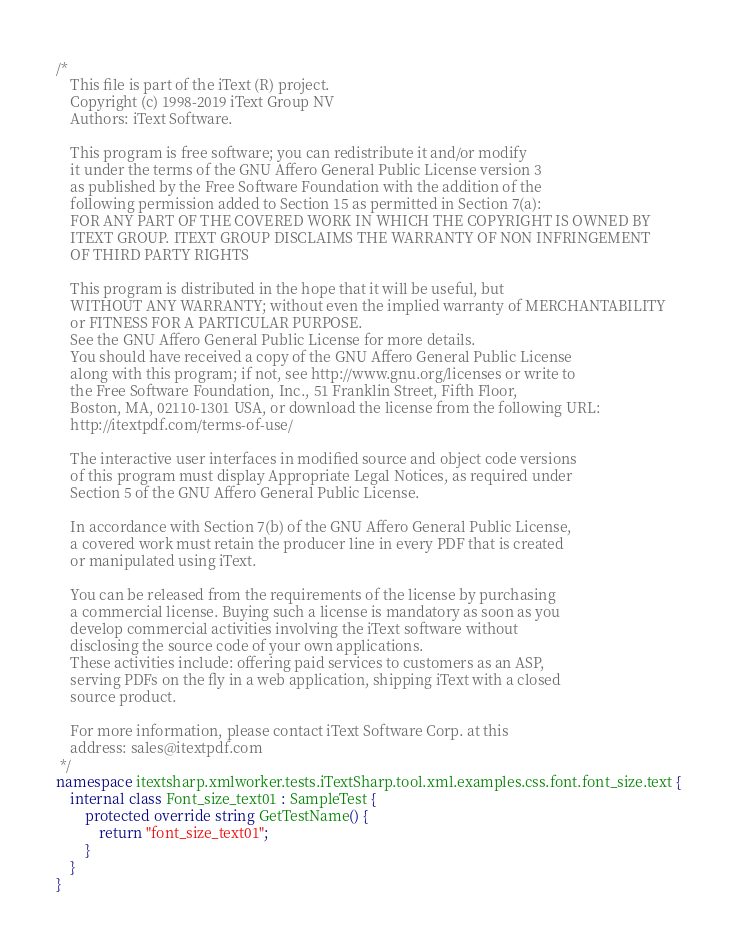Convert code to text. <code><loc_0><loc_0><loc_500><loc_500><_C#_>/*
    This file is part of the iText (R) project.
    Copyright (c) 1998-2019 iText Group NV
    Authors: iText Software.

    This program is free software; you can redistribute it and/or modify
    it under the terms of the GNU Affero General Public License version 3
    as published by the Free Software Foundation with the addition of the
    following permission added to Section 15 as permitted in Section 7(a):
    FOR ANY PART OF THE COVERED WORK IN WHICH THE COPYRIGHT IS OWNED BY
    ITEXT GROUP. ITEXT GROUP DISCLAIMS THE WARRANTY OF NON INFRINGEMENT
    OF THIRD PARTY RIGHTS
    
    This program is distributed in the hope that it will be useful, but
    WITHOUT ANY WARRANTY; without even the implied warranty of MERCHANTABILITY
    or FITNESS FOR A PARTICULAR PURPOSE.
    See the GNU Affero General Public License for more details.
    You should have received a copy of the GNU Affero General Public License
    along with this program; if not, see http://www.gnu.org/licenses or write to
    the Free Software Foundation, Inc., 51 Franklin Street, Fifth Floor,
    Boston, MA, 02110-1301 USA, or download the license from the following URL:
    http://itextpdf.com/terms-of-use/
    
    The interactive user interfaces in modified source and object code versions
    of this program must display Appropriate Legal Notices, as required under
    Section 5 of the GNU Affero General Public License.
    
    In accordance with Section 7(b) of the GNU Affero General Public License,
    a covered work must retain the producer line in every PDF that is created
    or manipulated using iText.
    
    You can be released from the requirements of the license by purchasing
    a commercial license. Buying such a license is mandatory as soon as you
    develop commercial activities involving the iText software without
    disclosing the source code of your own applications.
    These activities include: offering paid services to customers as an ASP,
    serving PDFs on the fly in a web application, shipping iText with a closed
    source product.
    
    For more information, please contact iText Software Corp. at this
    address: sales@itextpdf.com
 */
namespace itextsharp.xmlworker.tests.iTextSharp.tool.xml.examples.css.font.font_size.text {
    internal class Font_size_text01 : SampleTest {
        protected override string GetTestName() {
            return "font_size_text01";
        }
    }
}
</code> 